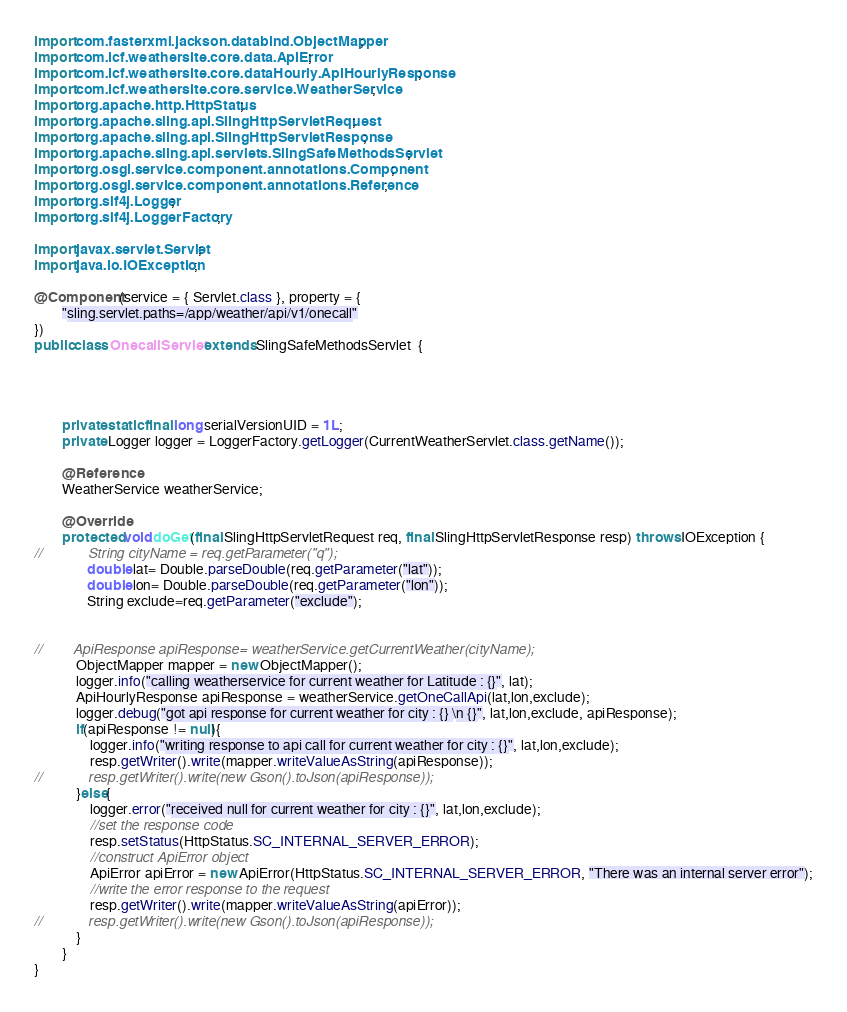<code> <loc_0><loc_0><loc_500><loc_500><_Java_>
import com.fasterxml.jackson.databind.ObjectMapper;
import com.icf.weathersite.core.data.ApiError;
import com.icf.weathersite.core.dataHourly.ApiHourlyResponse;
import com.icf.weathersite.core.service.WeatherService;
import org.apache.http.HttpStatus;
import org.apache.sling.api.SlingHttpServletRequest;
import org.apache.sling.api.SlingHttpServletResponse;
import org.apache.sling.api.servlets.SlingSafeMethodsServlet;
import org.osgi.service.component.annotations.Component;
import org.osgi.service.component.annotations.Reference;
import org.slf4j.Logger;
import org.slf4j.LoggerFactory;

import javax.servlet.Servlet;
import java.io.IOException;

@Component(service = { Servlet.class }, property = {
        "sling.servlet.paths=/app/weather/api/v1/onecall"
})
public class OnecallServlet extends SlingSafeMethodsServlet  {




        private static final long serialVersionUID = 1L;
        private Logger logger = LoggerFactory.getLogger(CurrentWeatherServlet.class.getName());

        @Reference
        WeatherService weatherService;

        @Override
        protected void doGet(final SlingHttpServletRequest req, final SlingHttpServletResponse resp) throws IOException {
//            String cityName = req.getParameter("q");
               double lat= Double.parseDouble(req.getParameter("lat"));
               double lon= Double.parseDouble(req.getParameter("lon"));
               String exclude=req.getParameter("exclude");


//        ApiResponse apiResponse= weatherService.getCurrentWeather(cityName);
            ObjectMapper mapper = new ObjectMapper();
            logger.info("calling weatherservice for current weather for Latitude : {}", lat);
            ApiHourlyResponse apiResponse = weatherService.getOneCallApi(lat,lon,exclude);
            logger.debug("got api response for current weather for city : {} \n {}", lat,lon,exclude, apiResponse);
            if(apiResponse != null){
                logger.info("writing response to api call for current weather for city : {}", lat,lon,exclude);
                resp.getWriter().write(mapper.writeValueAsString(apiResponse));
//            resp.getWriter().write(new Gson().toJson(apiResponse));
            }else{
                logger.error("received null for current weather for city : {}", lat,lon,exclude);
                //set the response code
                resp.setStatus(HttpStatus.SC_INTERNAL_SERVER_ERROR);
                //construct ApiError object
                ApiError apiError = new ApiError(HttpStatus.SC_INTERNAL_SERVER_ERROR, "There was an internal server error");
                //write the error response to the request
                resp.getWriter().write(mapper.writeValueAsString(apiError));
//            resp.getWriter().write(new Gson().toJson(apiResponse));
            }
        }
}
</code> 